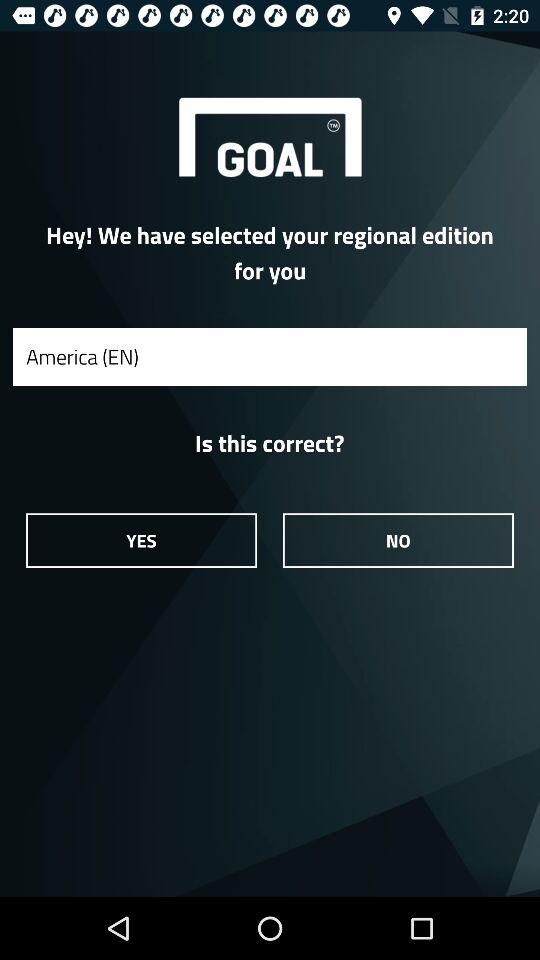Who is this application powered by?
When the provided information is insufficient, respond with <no answer>. <no answer> 